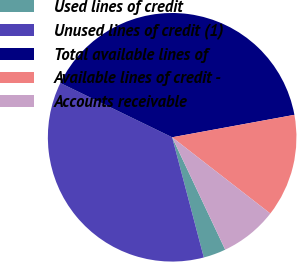Convert chart to OTSL. <chart><loc_0><loc_0><loc_500><loc_500><pie_chart><fcel>Used lines of credit<fcel>Unused lines of credit (1)<fcel>Total available lines of<fcel>Available lines of credit -<fcel>Accounts receivable<nl><fcel>2.92%<fcel>36.29%<fcel>39.92%<fcel>13.4%<fcel>7.47%<nl></chart> 